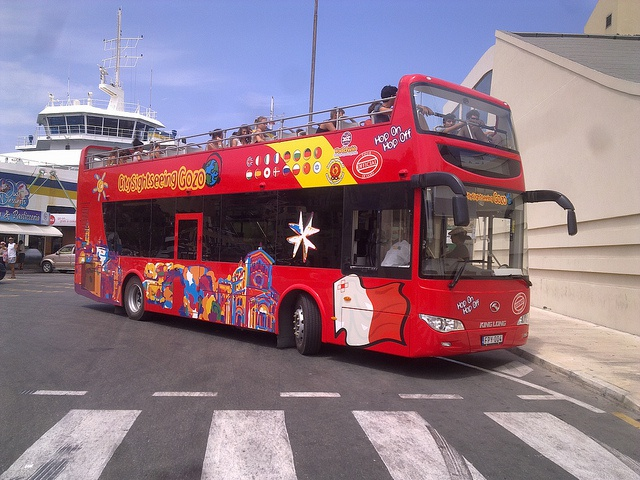Describe the objects in this image and their specific colors. I can see bus in darkgray, black, brown, and gray tones, boat in darkgray, white, gray, and lavender tones, people in darkgray, gray, lavender, and brown tones, car in darkgray, gray, and black tones, and people in darkgray, purple, black, and lightblue tones in this image. 